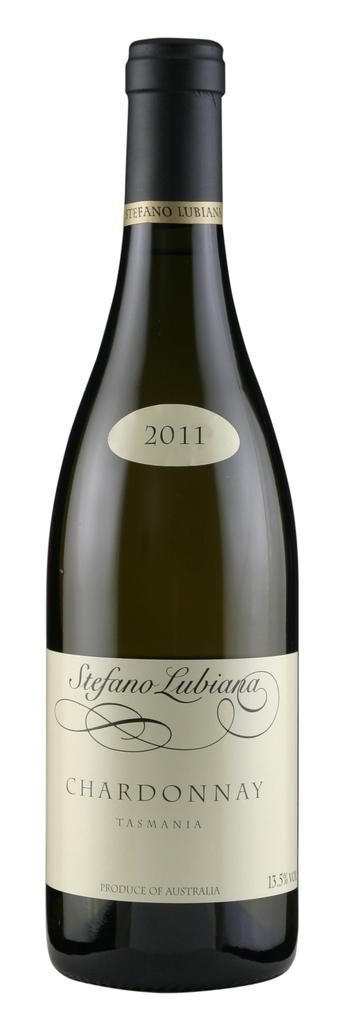Provide a one-sentence caption for the provided image. new bottle of chardonnay  from 2011 sits on counter. 